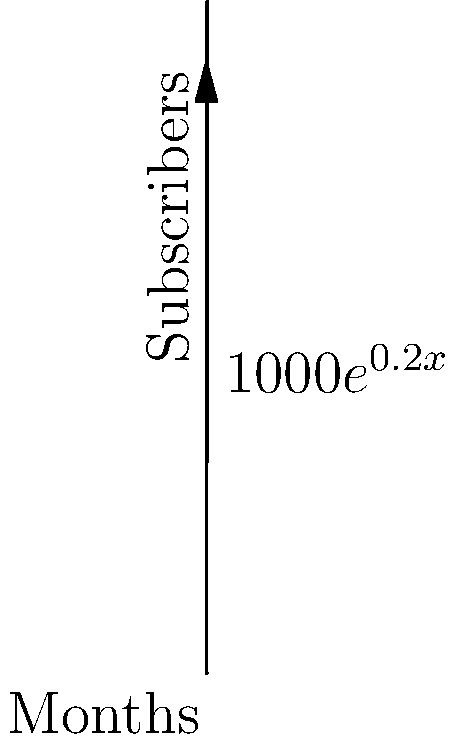Sarah, a working mother, started an inspirational podcast to share uplifting news. The growth of her subscribers follows the exponential function $S(t) = 1000e^{0.2t}$, where $S$ is the number of subscribers and $t$ is the time in months. How many months will it take for Sarah's podcast to reach 5000 subscribers? Let's approach this step-by-step:

1) We need to solve the equation: $5000 = 1000e^{0.2t}$

2) Divide both sides by 1000:
   $5 = e^{0.2t}$

3) Take the natural logarithm of both sides:
   $\ln(5) = \ln(e^{0.2t})$

4) Simplify the right side using the properties of logarithms:
   $\ln(5) = 0.2t$

5) Divide both sides by 0.2:
   $\frac{\ln(5)}{0.2} = t$

6) Calculate the result:
   $t \approx 8.05$ months

7) Since we can't have a fractional month, we round up to the next whole month.
Answer: 9 months 